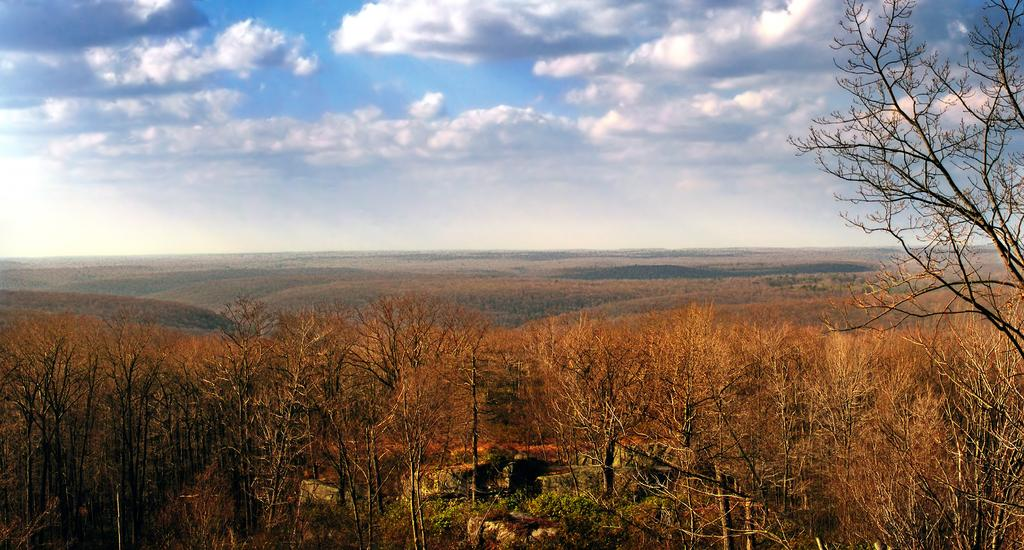What type of vegetation can be seen on the hill in the image? There are trees and plants on the ground of a hill in the image. What can be seen in the distance behind the hill? In the background, there are mountains visible. What is the condition of the sky in the image? The sky is blue, and there are clouds visible in it. Is there a flag flying on top of the hill in the image? There is no flag mentioned or visible in the image. Are there any slaves or beasts present in the image? There is no mention or indication of slaves or beasts in the image. 